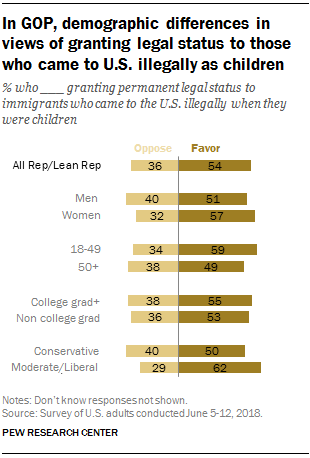List a handful of essential elements in this visual. The missing data in the list of numbers "54, 51, 57, 59, 49, 55, 53, 62" is 50. According to the data, men are more likely to oppose something than women, with a ratio of approximately 1.25. 